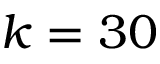Convert formula to latex. <formula><loc_0><loc_0><loc_500><loc_500>k = 3 0</formula> 